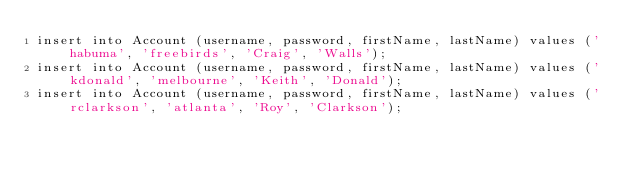<code> <loc_0><loc_0><loc_500><loc_500><_SQL_>insert into Account (username, password, firstName, lastName) values ('habuma', 'freebirds', 'Craig', 'Walls');
insert into Account (username, password, firstName, lastName) values ('kdonald', 'melbourne', 'Keith', 'Donald');
insert into Account (username, password, firstName, lastName) values ('rclarkson', 'atlanta', 'Roy', 'Clarkson');

</code> 